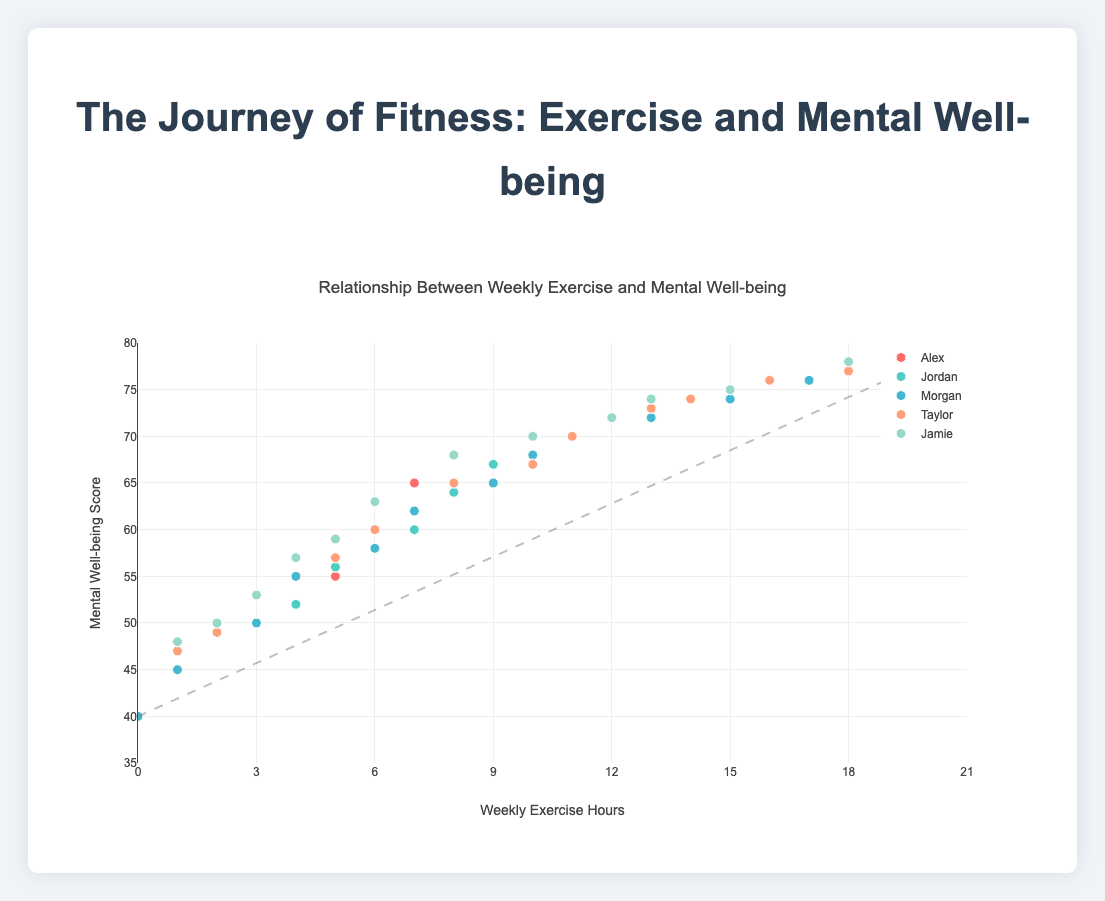What is the title of the scatter plot? The title of the scatter plot is usually placed at the top center of the chart.
Answer: Relationship Between Weekly Exercise and Mental Well-being What is the range of weekly exercise hours shown in the x-axis? The x-axis of the scatter plot ranges from 0 to 21 hours, as indicated by the axis labels.
Answer: 0 to 21 hours Which individual has the highest mental well-being score, and what is that score? By looking at the y-axis (mental well-being scores), Jamie has the highest score of 78, which is shown at the 18 weekly exercise hours mark.
Answer: Jamie, 78 How many individuals are represented in the scatter plot? Each individual is indicated by a different colored marker, and there are 5 distinct sets of markers.
Answer: 5 What color represents Taylor's data points? The legend indicates that Taylor's data points are represented by the color peach.
Answer: Peach What is the general trend observed in the plot between weekly exercise hours and mental well-being scores? The trend line indicates that as weekly exercise hours increase, mental well-being scores generally also increase, as shown by the positive slope of the line drawn through the data points.
Answer: Positive correlation Which individual has data points at the lowest mental well-being score, and what is that score? Morgan has the lowest mental well-being score of 40, which corresponds to 0 weekly exercise hours, as observed from the y-axis and its data points.
Answer: Morgan, 40 What is the average mental well-being score for Alex’s data points? By summing Alex's mental well-being scores (45 + 50 + 55 + 60 + 65 + 68 + 70 + 72 + 74 + 75 + 76 + 77) and dividing by the number of points (12): (787 / 12).
Answer: 65.58 Does anyone have the same mental well-being score for different exercise hours? If so, who and what are the hours? Jordan has a mental well-being score of 72 at both 12 and 13 weekly exercise hours, as shown by the identical y-axis values.
Answer: Jordan, 12 and 13 hours At what weekly exercise hour does the trend line intersect a mental well-being score of 60? The intersection of the trend line with a mental well-being score of 60 is roughly at weekly exercise hours between 6 and 7 as estimated visually from the plot.
Answer: Between 6 and 7 hours 